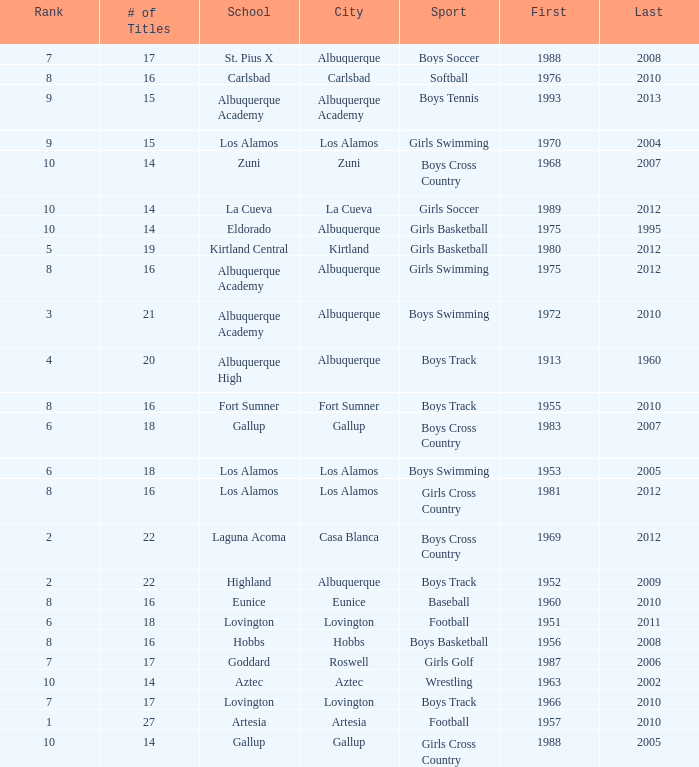What is the highest rank for the boys swimming team in Albuquerque? 3.0. 